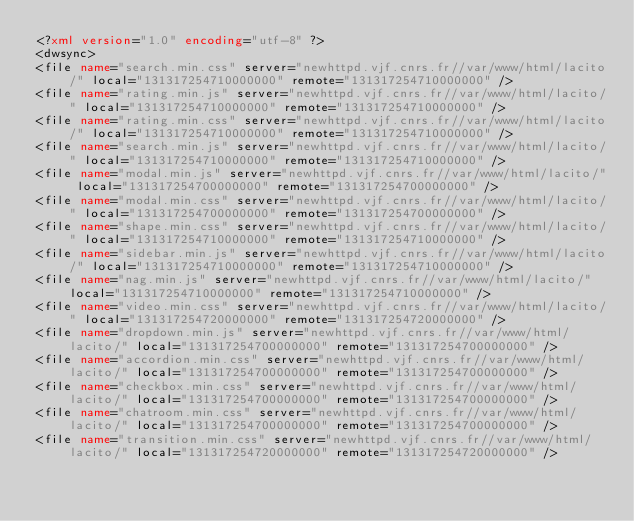Convert code to text. <code><loc_0><loc_0><loc_500><loc_500><_XML_><?xml version="1.0" encoding="utf-8" ?>
<dwsync>
<file name="search.min.css" server="newhttpd.vjf.cnrs.fr//var/www/html/lacito/" local="131317254710000000" remote="131317254710000000" />
<file name="rating.min.js" server="newhttpd.vjf.cnrs.fr//var/www/html/lacito/" local="131317254710000000" remote="131317254710000000" />
<file name="rating.min.css" server="newhttpd.vjf.cnrs.fr//var/www/html/lacito/" local="131317254710000000" remote="131317254710000000" />
<file name="search.min.js" server="newhttpd.vjf.cnrs.fr//var/www/html/lacito/" local="131317254710000000" remote="131317254710000000" />
<file name="modal.min.js" server="newhttpd.vjf.cnrs.fr//var/www/html/lacito/" local="131317254700000000" remote="131317254700000000" />
<file name="modal.min.css" server="newhttpd.vjf.cnrs.fr//var/www/html/lacito/" local="131317254700000000" remote="131317254700000000" />
<file name="shape.min.css" server="newhttpd.vjf.cnrs.fr//var/www/html/lacito/" local="131317254710000000" remote="131317254710000000" />
<file name="sidebar.min.js" server="newhttpd.vjf.cnrs.fr//var/www/html/lacito/" local="131317254710000000" remote="131317254710000000" />
<file name="nag.min.js" server="newhttpd.vjf.cnrs.fr//var/www/html/lacito/" local="131317254710000000" remote="131317254710000000" />
<file name="video.min.css" server="newhttpd.vjf.cnrs.fr//var/www/html/lacito/" local="131317254720000000" remote="131317254720000000" />
<file name="dropdown.min.js" server="newhttpd.vjf.cnrs.fr//var/www/html/lacito/" local="131317254700000000" remote="131317254700000000" />
<file name="accordion.min.css" server="newhttpd.vjf.cnrs.fr//var/www/html/lacito/" local="131317254700000000" remote="131317254700000000" />
<file name="checkbox.min.css" server="newhttpd.vjf.cnrs.fr//var/www/html/lacito/" local="131317254700000000" remote="131317254700000000" />
<file name="chatroom.min.css" server="newhttpd.vjf.cnrs.fr//var/www/html/lacito/" local="131317254700000000" remote="131317254700000000" />
<file name="transition.min.css" server="newhttpd.vjf.cnrs.fr//var/www/html/lacito/" local="131317254720000000" remote="131317254720000000" /></code> 